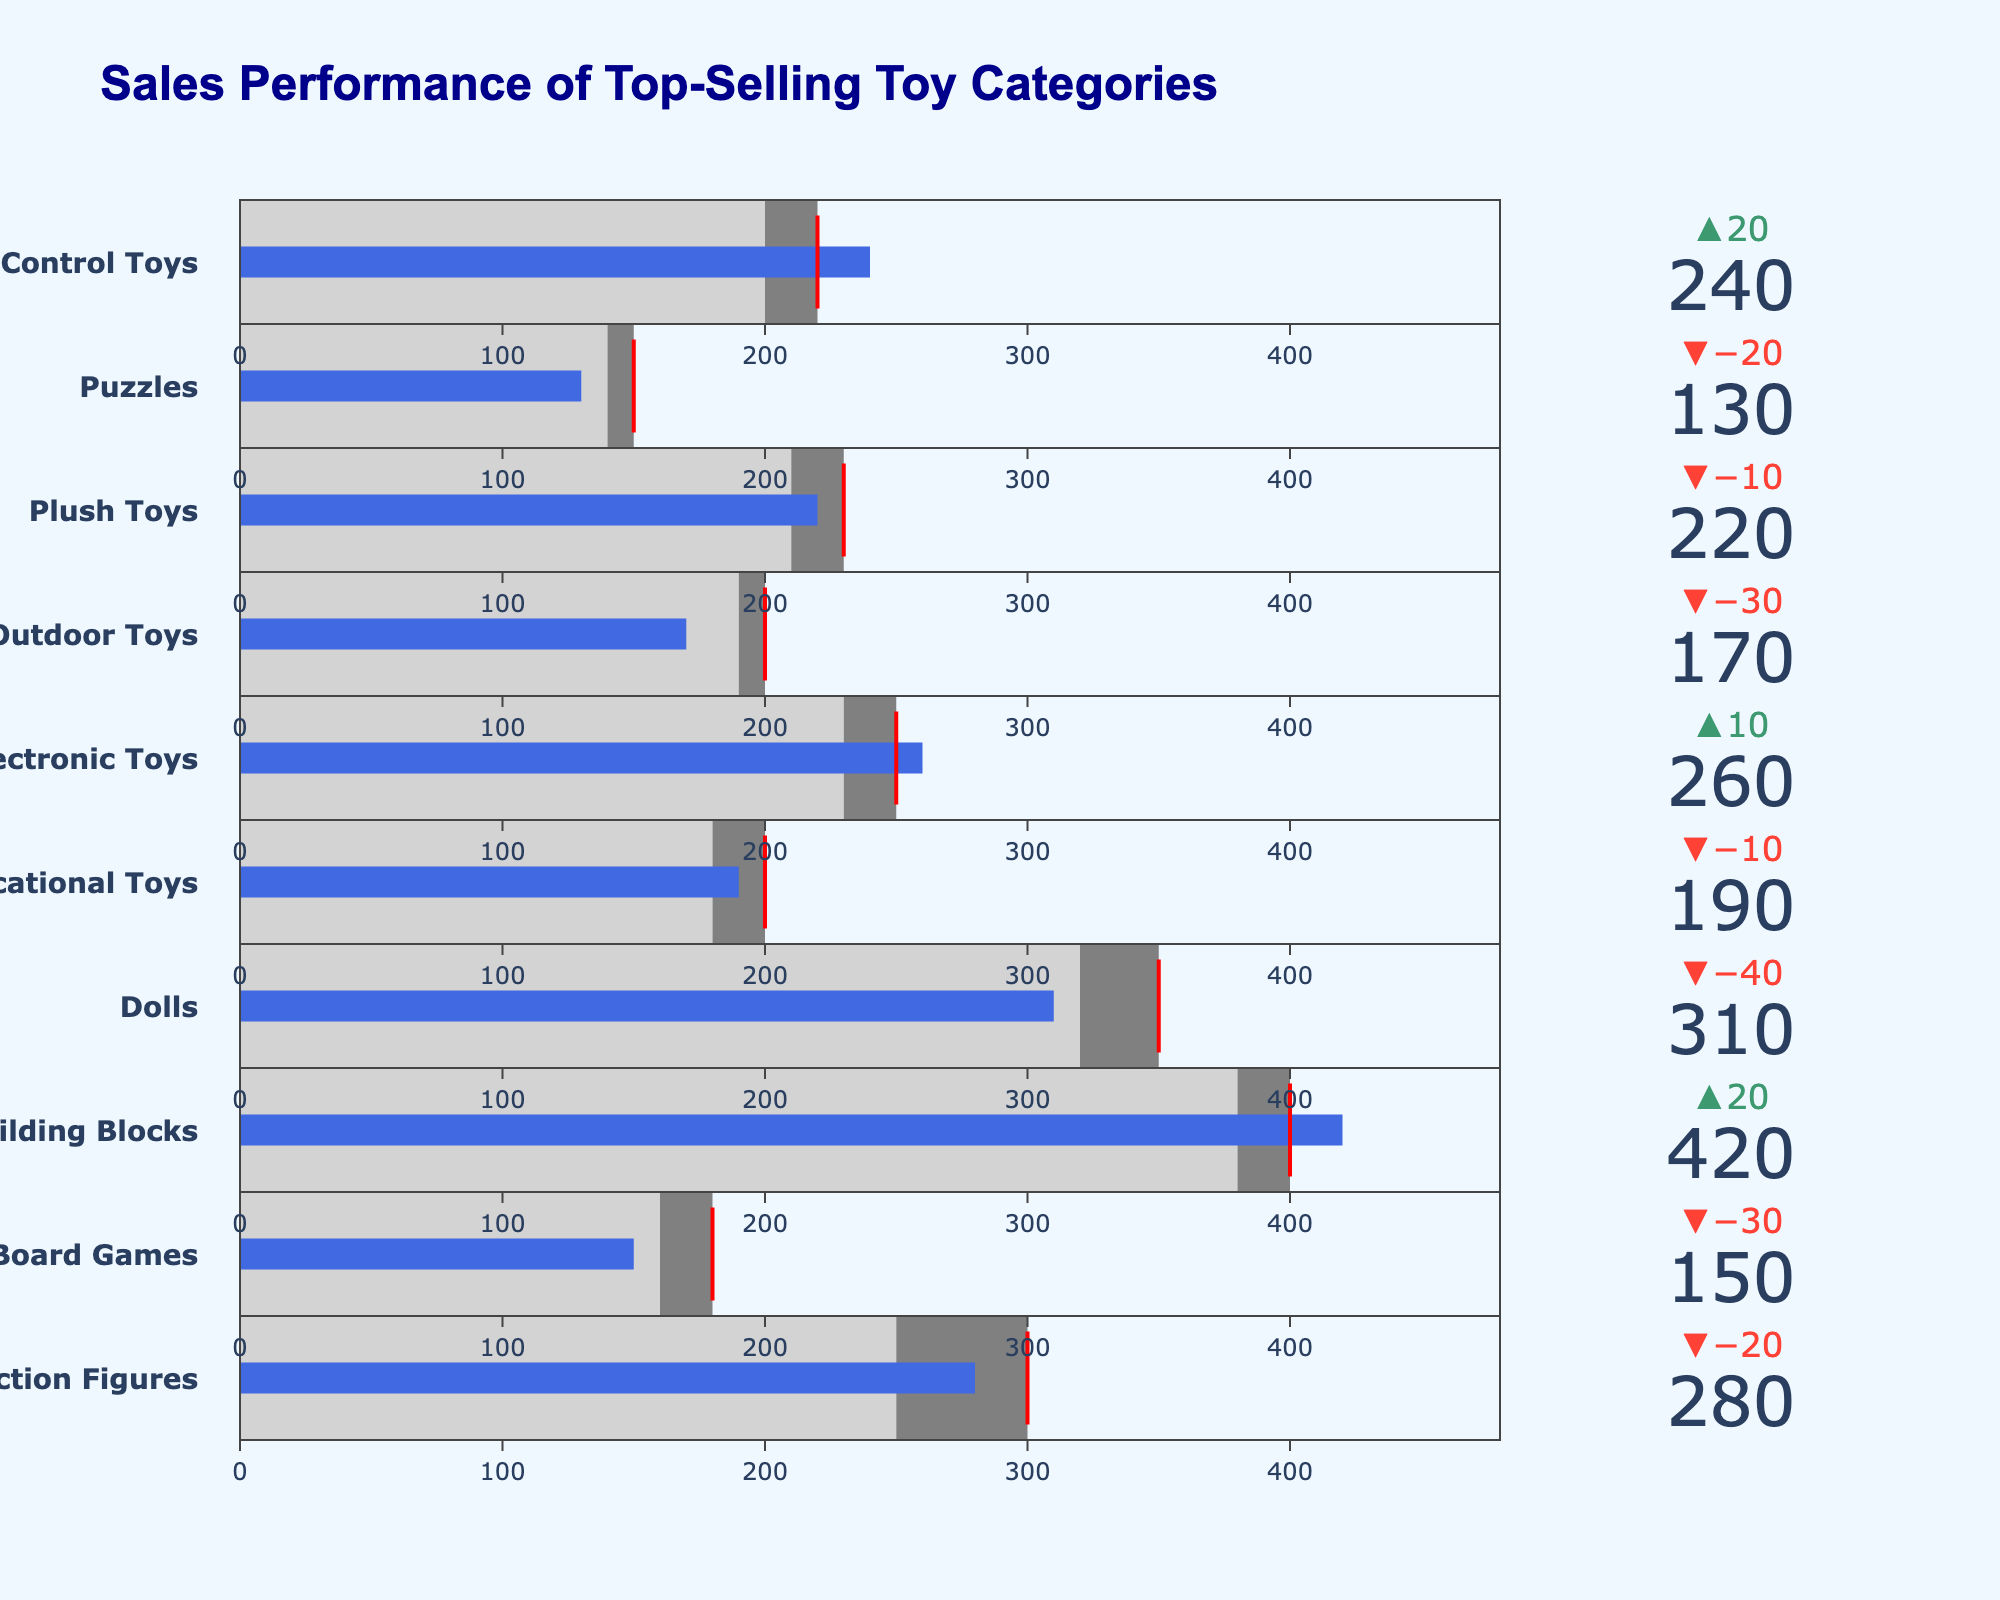What's the highest actual sales value among the toy categories? Look at the bar lengths for each toy category and find the one with the longest bar, which indicates the highest actual sales. Building Blocks has the longest bar.
Answer: Building Blocks Which toy category exceeded its sales target by the largest margin? Compare the difference between actual sales and the target for each category. The largest positive difference indicates the category that exceeded its target the most. Building Blocks (420 - 400 = 20) is the largest.
Answer: Building Blocks Did any toy category's actual sales fall between the comparator and the target? Check if any bar starts above the comparator value and ends below the target value. Outdoor Toys has actual sales of 170, falling between comparator 190 and target 200.
Answer: Outdoor Toys Among Electronic Toys and Remote Control Toys, which one performed better against its sales target? Compare the actual sales and targets for both categories and see which has a higher value relative to its target. Electronic Toys (260 vs. 250) performed better than Remote Control Toys (240 vs. 220).
Answer: Electronic Toys How much higher are the actual sales of Dolls compared to Puzzles? Subtract the actual sales of Puzzles from Dolls to find the difference. Dolls' actual sales are 310, Puzzles are 130, so 310 - 130 = 180.
Answer: 180 Which category came closest to meeting its sales target but missed it? Look for the category with the smallest negative difference between actual sales and target. Dolls missed its target by 40 (350 - 310).
Answer: Dolls What is the average target sales value across all categories? Add all the target values and divide by the number of categories (300 + 180 + 400 + 350 + 200 + 250 + 200 + 230 +150 + 220 = 2480). There are 10 categories, so 2480 / 10 = 248.
Answer: 248 Do any categories have actual sales close to the comparator values? Identify categories where actual sales are around the comparator values. For Electronic Toys, the actual sales (260) are close to the comparator (230).
Answer: Electronic Toys What is the overall performance trend seen in the figure? Overall, observe if more categories are exceeding, meeting, or falling short of their targets. Look for patterns in the bullet charts. Generally, more categories are either close to or exceeding their targets with a few underperforming.
Answer: Mixed performance 